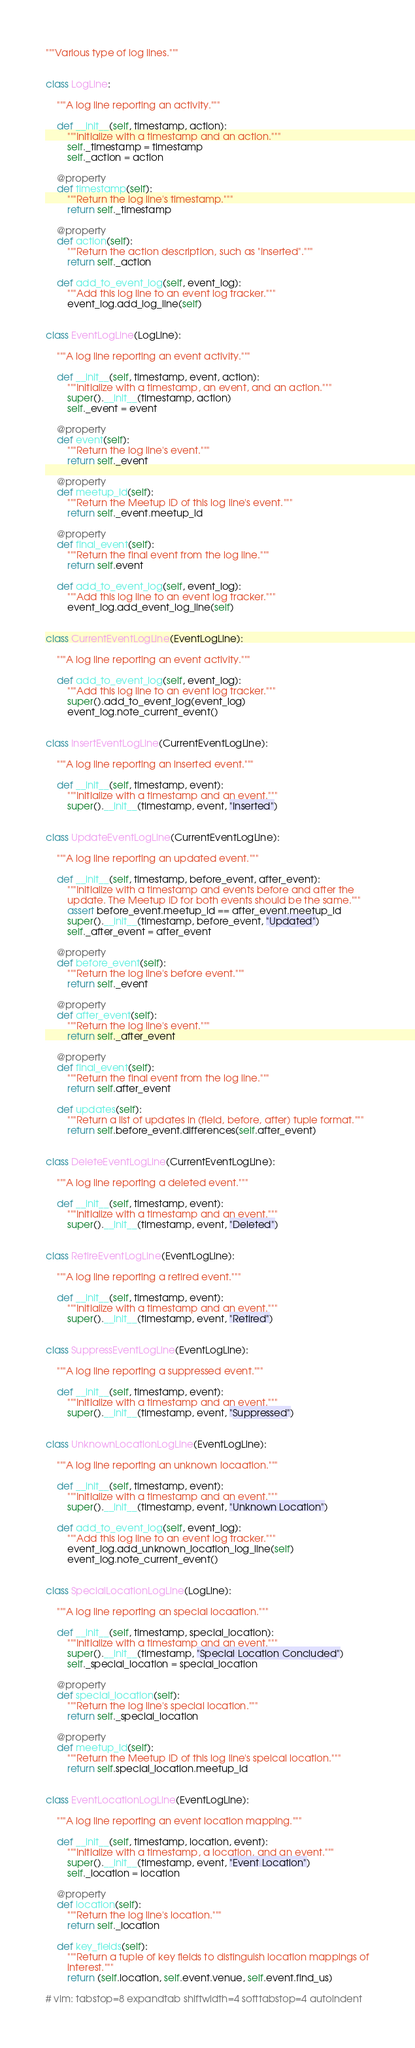<code> <loc_0><loc_0><loc_500><loc_500><_Python_>"""Various type of log lines."""


class LogLine:

    """A log line reporting an activity."""

    def __init__(self, timestamp, action):
        """Initialize with a timestamp and an action."""
        self._timestamp = timestamp
        self._action = action

    @property
    def timestamp(self):
        """Return the log line's timestamp."""
        return self._timestamp

    @property
    def action(self):
        """Return the action description, such as "Inserted"."""
        return self._action

    def add_to_event_log(self, event_log):
        """Add this log line to an event log tracker."""
        event_log.add_log_line(self)


class EventLogLine(LogLine):

    """A log line reporting an event activity."""

    def __init__(self, timestamp, event, action):
        """Initialize with a timestamp, an event, and an action."""
        super().__init__(timestamp, action)
        self._event = event

    @property
    def event(self):
        """Return the log line's event."""
        return self._event

    @property
    def meetup_id(self):
        """Return the Meetup ID of this log line's event."""
        return self._event.meetup_id

    @property
    def final_event(self):
        """Return the final event from the log line."""
        return self.event

    def add_to_event_log(self, event_log):
        """Add this log line to an event log tracker."""
        event_log.add_event_log_line(self)


class CurrentEventLogLine(EventLogLine):

    """A log line reporting an event activity."""

    def add_to_event_log(self, event_log):
        """Add this log line to an event log tracker."""
        super().add_to_event_log(event_log)
        event_log.note_current_event()


class InsertEventLogLine(CurrentEventLogLine):

    """A log line reporting an inserted event."""

    def __init__(self, timestamp, event):
        """Initialize with a timestamp and an event."""
        super().__init__(timestamp, event, "Inserted")


class UpdateEventLogLine(CurrentEventLogLine):

    """A log line reporting an updated event."""

    def __init__(self, timestamp, before_event, after_event):
        """Initialize with a timestamp and events before and after the
        update. The Meetup ID for both events should be the same."""
        assert before_event.meetup_id == after_event.meetup_id
        super().__init__(timestamp, before_event, "Updated")
        self._after_event = after_event

    @property
    def before_event(self):
        """Return the log line's before event."""
        return self._event

    @property
    def after_event(self):
        """Return the log line's event."""
        return self._after_event

    @property
    def final_event(self):
        """Return the final event from the log line."""
        return self.after_event

    def updates(self):
        """Return a list of updates in (field, before, after) tuple format."""
        return self.before_event.differences(self.after_event)


class DeleteEventLogLine(CurrentEventLogLine):

    """A log line reporting a deleted event."""

    def __init__(self, timestamp, event):
        """Initialize with a timestamp and an event."""
        super().__init__(timestamp, event, "Deleted")


class RetireEventLogLine(EventLogLine):

    """A log line reporting a retired event."""

    def __init__(self, timestamp, event):
        """Initialize with a timestamp and an event."""
        super().__init__(timestamp, event, "Retired")


class SuppressEventLogLine(EventLogLine):

    """A log line reporting a suppressed event."""

    def __init__(self, timestamp, event):
        """Initialize with a timestamp and an event."""
        super().__init__(timestamp, event, "Suppressed")


class UnknownLocationLogLine(EventLogLine):

    """A log line reporting an unknown locaation."""

    def __init__(self, timestamp, event):
        """Initialize with a timestamp and an event."""
        super().__init__(timestamp, event, "Unknown Location")

    def add_to_event_log(self, event_log):
        """Add this log line to an event log tracker."""
        event_log.add_unknown_location_log_line(self)
        event_log.note_current_event()


class SpecialLocationLogLine(LogLine):

    """A log line reporting an special locaation."""

    def __init__(self, timestamp, special_location):
        """Initialize with a timestamp and an event."""
        super().__init__(timestamp, "Special Location Concluded")
        self._special_location = special_location

    @property
    def special_location(self):
        """Return the log line's special location."""
        return self._special_location

    @property
    def meetup_id(self):
        """Return the Meetup ID of this log line's speical location."""
        return self.special_location.meetup_id


class EventLocationLogLine(EventLogLine):

    """A log line reporting an event location mapping."""

    def __init__(self, timestamp, location, event):
        """Initialize with a timestamp, a location, and an event."""
        super().__init__(timestamp, event, "Event Location")
        self._location = location

    @property
    def location(self):
        """Return the log line's location."""
        return self._location

    def key_fields(self):
        """Return a tuple of key fields to distinguish location mappings of
        interest."""
        return (self.location, self.event.venue, self.event.find_us)

# vim: tabstop=8 expandtab shiftwidth=4 softtabstop=4 autoindent
</code> 